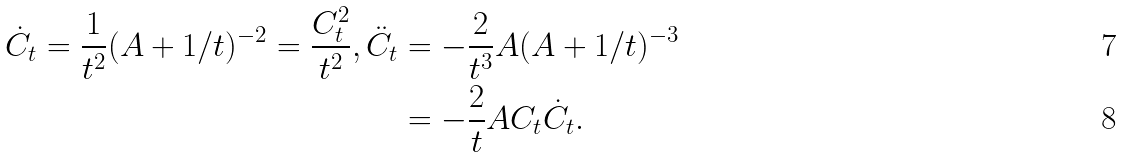Convert formula to latex. <formula><loc_0><loc_0><loc_500><loc_500>\dot { C } _ { t } = \frac { 1 } { t ^ { 2 } } ( A + 1 / t ) ^ { - 2 } = \frac { C ^ { 2 } _ { t } } { t ^ { 2 } } , \ddot { C } _ { t } & = - \frac { 2 } { t ^ { 3 } } A ( A + 1 / t ) ^ { - 3 } \\ & = - \frac { 2 } { t } A C _ { t } \dot { C } _ { t } .</formula> 